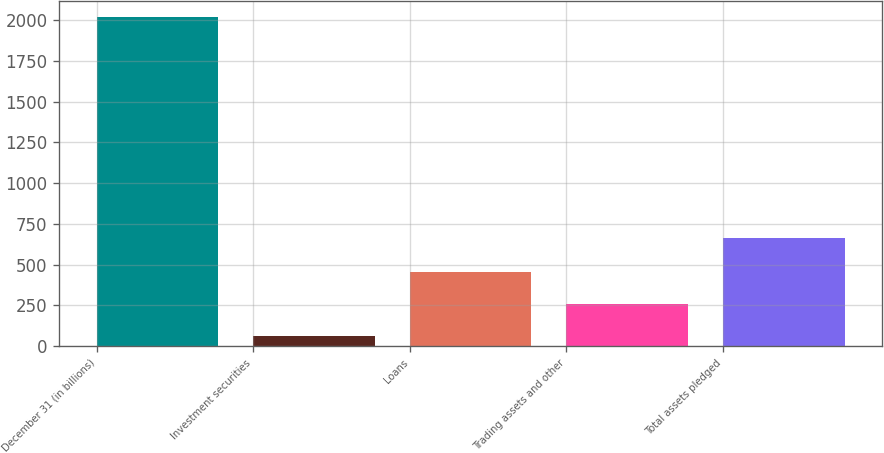Convert chart. <chart><loc_0><loc_0><loc_500><loc_500><bar_chart><fcel>December 31 (in billions)<fcel>Investment securities<fcel>Loans<fcel>Trading assets and other<fcel>Total assets pledged<nl><fcel>2018<fcel>59.5<fcel>451.2<fcel>255.35<fcel>663<nl></chart> 